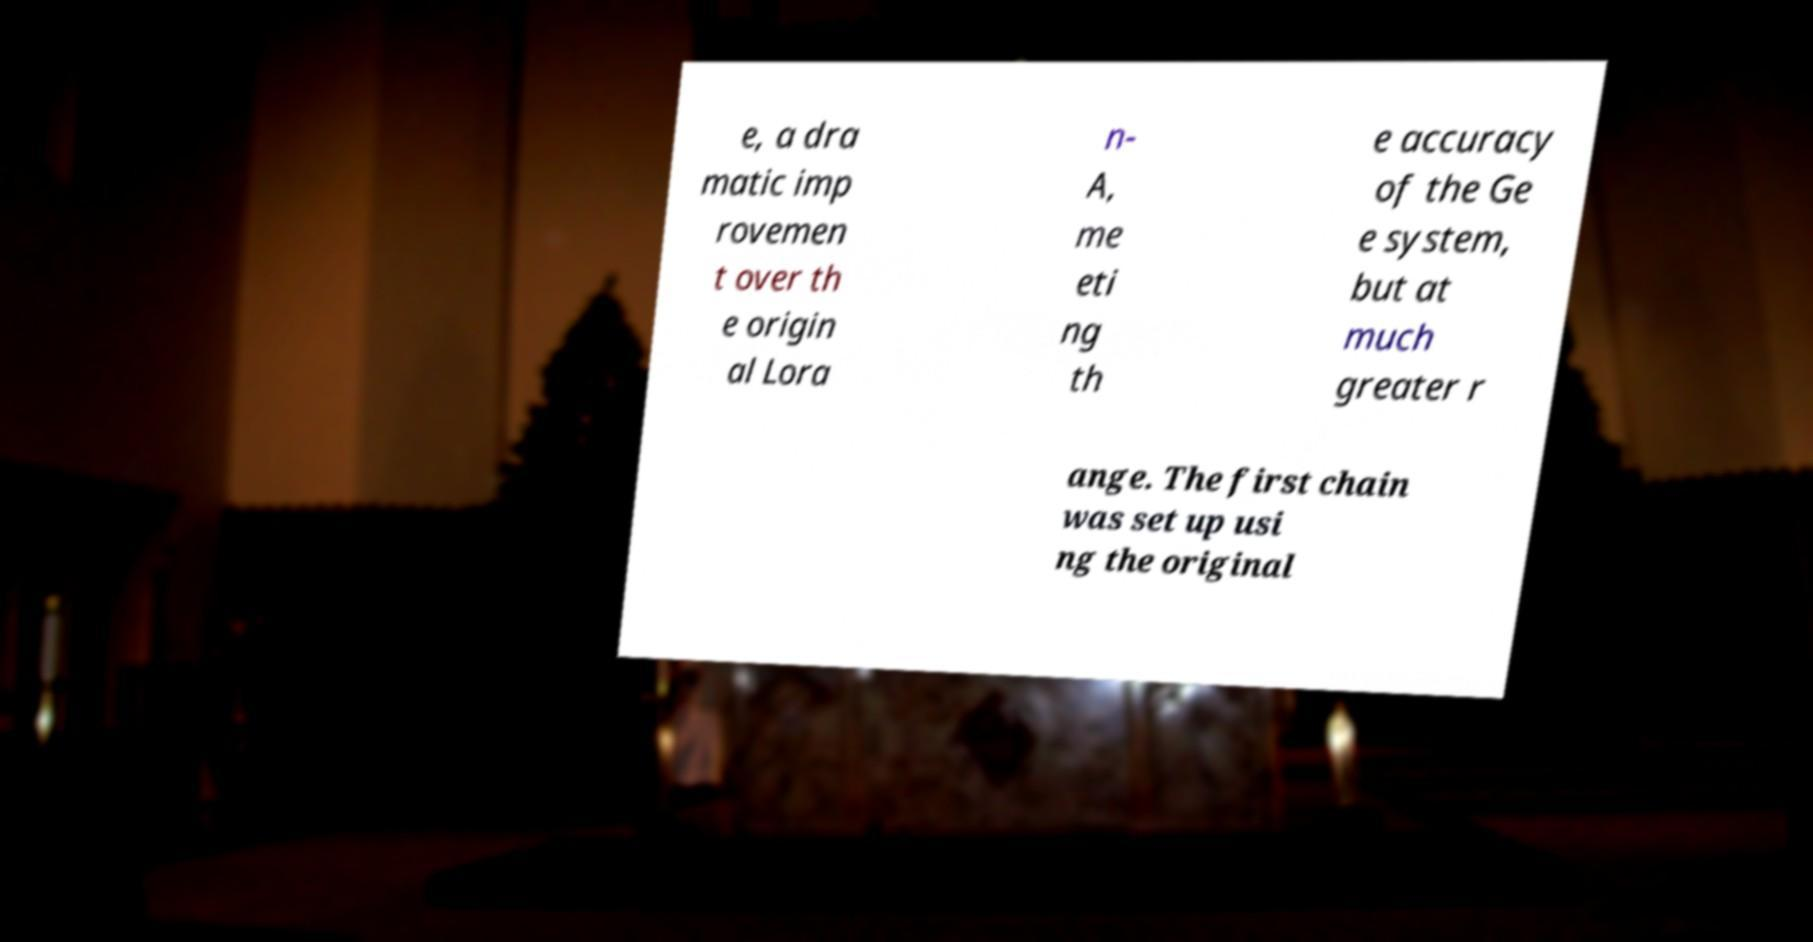Can you accurately transcribe the text from the provided image for me? e, a dra matic imp rovemen t over th e origin al Lora n- A, me eti ng th e accuracy of the Ge e system, but at much greater r ange. The first chain was set up usi ng the original 